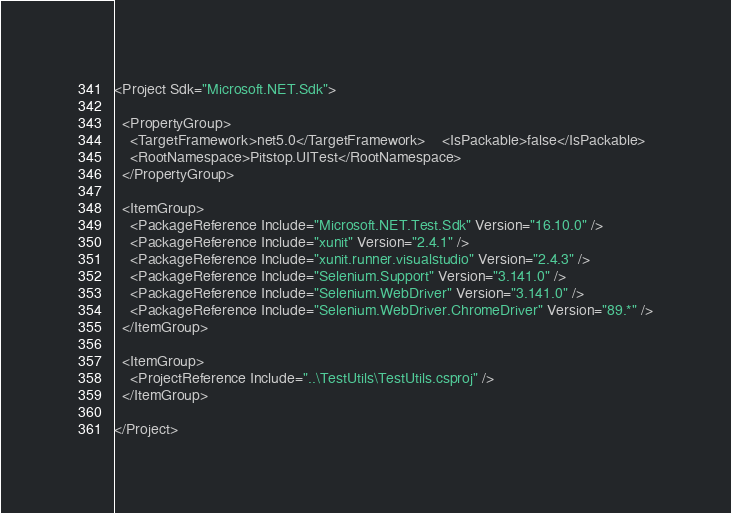Convert code to text. <code><loc_0><loc_0><loc_500><loc_500><_XML_><Project Sdk="Microsoft.NET.Sdk">

  <PropertyGroup>
    <TargetFramework>net5.0</TargetFramework>    <IsPackable>false</IsPackable>
    <RootNamespace>Pitstop.UITest</RootNamespace>
  </PropertyGroup>

  <ItemGroup>
    <PackageReference Include="Microsoft.NET.Test.Sdk" Version="16.10.0" />
    <PackageReference Include="xunit" Version="2.4.1" />
    <PackageReference Include="xunit.runner.visualstudio" Version="2.4.3" />
    <PackageReference Include="Selenium.Support" Version="3.141.0" />
    <PackageReference Include="Selenium.WebDriver" Version="3.141.0" />
    <PackageReference Include="Selenium.WebDriver.ChromeDriver" Version="89.*" />
  </ItemGroup>

  <ItemGroup>
    <ProjectReference Include="..\TestUtils\TestUtils.csproj" />
  </ItemGroup>  

</Project>
</code> 